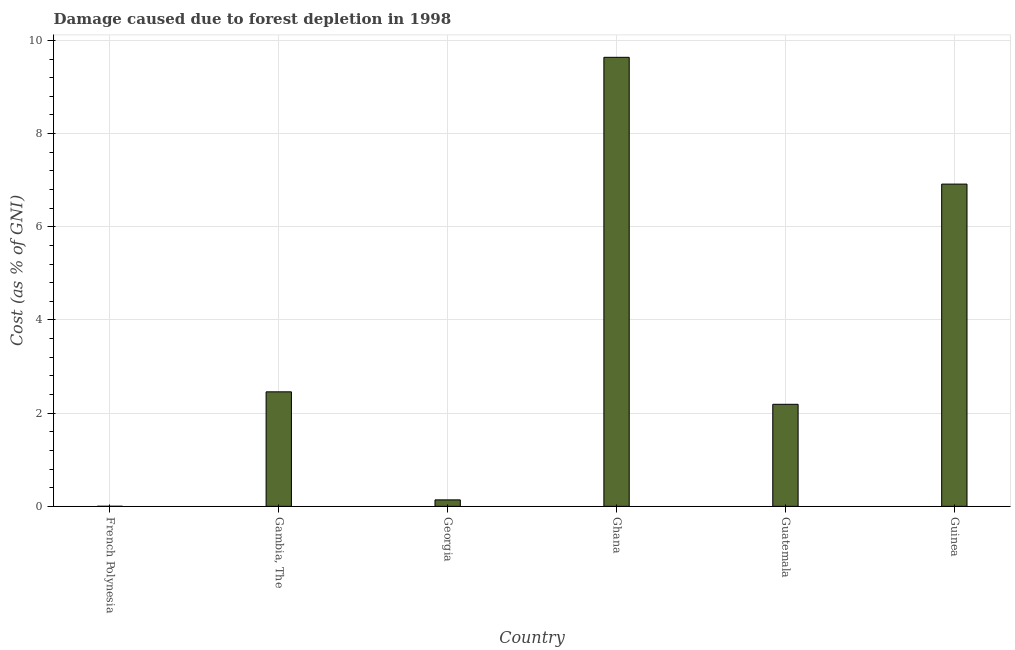Does the graph contain grids?
Keep it short and to the point. Yes. What is the title of the graph?
Offer a very short reply. Damage caused due to forest depletion in 1998. What is the label or title of the Y-axis?
Your answer should be compact. Cost (as % of GNI). What is the damage caused due to forest depletion in French Polynesia?
Your answer should be very brief. 0. Across all countries, what is the maximum damage caused due to forest depletion?
Ensure brevity in your answer.  9.64. Across all countries, what is the minimum damage caused due to forest depletion?
Keep it short and to the point. 0. In which country was the damage caused due to forest depletion maximum?
Your answer should be compact. Ghana. In which country was the damage caused due to forest depletion minimum?
Provide a succinct answer. French Polynesia. What is the sum of the damage caused due to forest depletion?
Your response must be concise. 21.34. What is the difference between the damage caused due to forest depletion in French Polynesia and Ghana?
Offer a very short reply. -9.63. What is the average damage caused due to forest depletion per country?
Ensure brevity in your answer.  3.56. What is the median damage caused due to forest depletion?
Ensure brevity in your answer.  2.32. What is the ratio of the damage caused due to forest depletion in Gambia, The to that in Georgia?
Make the answer very short. 17.7. Is the damage caused due to forest depletion in French Polynesia less than that in Georgia?
Your answer should be very brief. Yes. What is the difference between the highest and the second highest damage caused due to forest depletion?
Offer a terse response. 2.72. Is the sum of the damage caused due to forest depletion in Ghana and Guatemala greater than the maximum damage caused due to forest depletion across all countries?
Your answer should be compact. Yes. What is the difference between the highest and the lowest damage caused due to forest depletion?
Your answer should be compact. 9.64. How many bars are there?
Ensure brevity in your answer.  6. Are all the bars in the graph horizontal?
Ensure brevity in your answer.  No. How many countries are there in the graph?
Provide a short and direct response. 6. What is the Cost (as % of GNI) of French Polynesia?
Make the answer very short. 0. What is the Cost (as % of GNI) in Gambia, The?
Provide a short and direct response. 2.46. What is the Cost (as % of GNI) in Georgia?
Ensure brevity in your answer.  0.14. What is the Cost (as % of GNI) of Ghana?
Ensure brevity in your answer.  9.64. What is the Cost (as % of GNI) of Guatemala?
Keep it short and to the point. 2.19. What is the Cost (as % of GNI) of Guinea?
Give a very brief answer. 6.92. What is the difference between the Cost (as % of GNI) in French Polynesia and Gambia, The?
Make the answer very short. -2.46. What is the difference between the Cost (as % of GNI) in French Polynesia and Georgia?
Provide a short and direct response. -0.14. What is the difference between the Cost (as % of GNI) in French Polynesia and Ghana?
Make the answer very short. -9.64. What is the difference between the Cost (as % of GNI) in French Polynesia and Guatemala?
Your response must be concise. -2.19. What is the difference between the Cost (as % of GNI) in French Polynesia and Guinea?
Give a very brief answer. -6.91. What is the difference between the Cost (as % of GNI) in Gambia, The and Georgia?
Give a very brief answer. 2.32. What is the difference between the Cost (as % of GNI) in Gambia, The and Ghana?
Offer a terse response. -7.18. What is the difference between the Cost (as % of GNI) in Gambia, The and Guatemala?
Your answer should be compact. 0.27. What is the difference between the Cost (as % of GNI) in Gambia, The and Guinea?
Make the answer very short. -4.46. What is the difference between the Cost (as % of GNI) in Georgia and Ghana?
Provide a short and direct response. -9.5. What is the difference between the Cost (as % of GNI) in Georgia and Guatemala?
Your answer should be compact. -2.05. What is the difference between the Cost (as % of GNI) in Georgia and Guinea?
Make the answer very short. -6.78. What is the difference between the Cost (as % of GNI) in Ghana and Guatemala?
Provide a short and direct response. 7.45. What is the difference between the Cost (as % of GNI) in Ghana and Guinea?
Your response must be concise. 2.72. What is the difference between the Cost (as % of GNI) in Guatemala and Guinea?
Offer a very short reply. -4.73. What is the ratio of the Cost (as % of GNI) in French Polynesia to that in Gambia, The?
Provide a short and direct response. 0. What is the ratio of the Cost (as % of GNI) in French Polynesia to that in Georgia?
Provide a succinct answer. 0.01. What is the ratio of the Cost (as % of GNI) in French Polynesia to that in Ghana?
Give a very brief answer. 0. What is the ratio of the Cost (as % of GNI) in Gambia, The to that in Georgia?
Provide a succinct answer. 17.7. What is the ratio of the Cost (as % of GNI) in Gambia, The to that in Ghana?
Your answer should be very brief. 0.26. What is the ratio of the Cost (as % of GNI) in Gambia, The to that in Guatemala?
Your response must be concise. 1.12. What is the ratio of the Cost (as % of GNI) in Gambia, The to that in Guinea?
Ensure brevity in your answer.  0.35. What is the ratio of the Cost (as % of GNI) in Georgia to that in Ghana?
Provide a short and direct response. 0.01. What is the ratio of the Cost (as % of GNI) in Georgia to that in Guatemala?
Provide a short and direct response. 0.06. What is the ratio of the Cost (as % of GNI) in Ghana to that in Guinea?
Provide a short and direct response. 1.39. What is the ratio of the Cost (as % of GNI) in Guatemala to that in Guinea?
Offer a terse response. 0.32. 